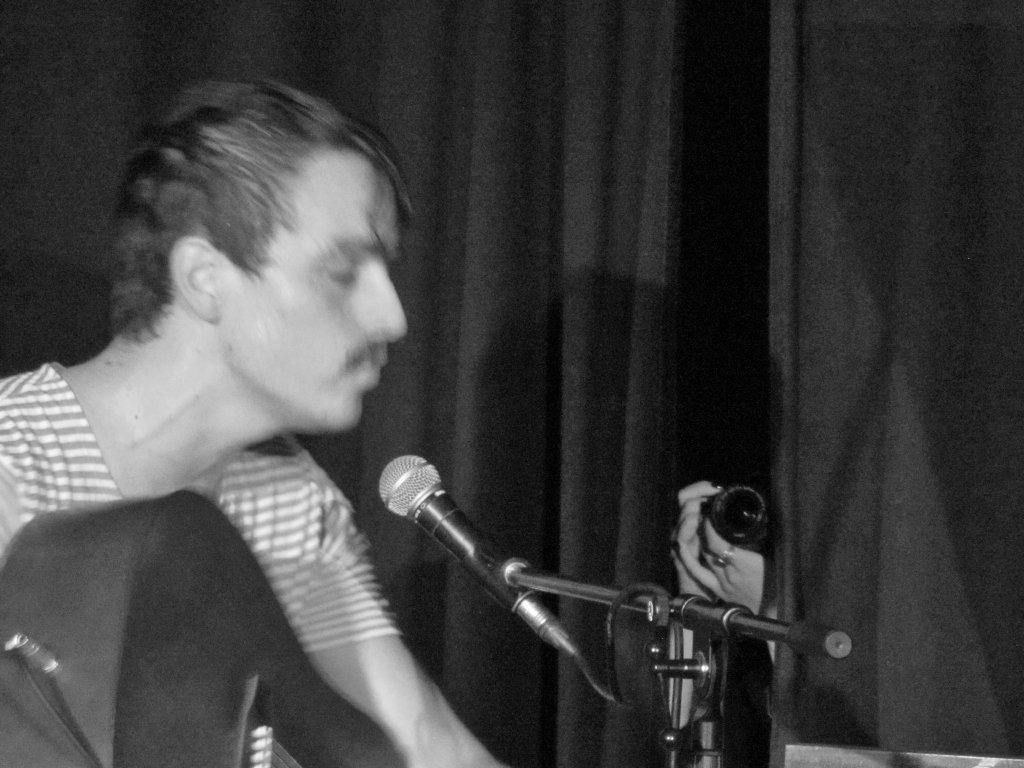Who or what is in the image? There is a person in the image. What is the person doing or interacting with in the image? The person is in front of a mic. What type of metal is the person's stomach made of in the image? There is no mention of the person's stomach or any metal in the image, so this question cannot be answered. 